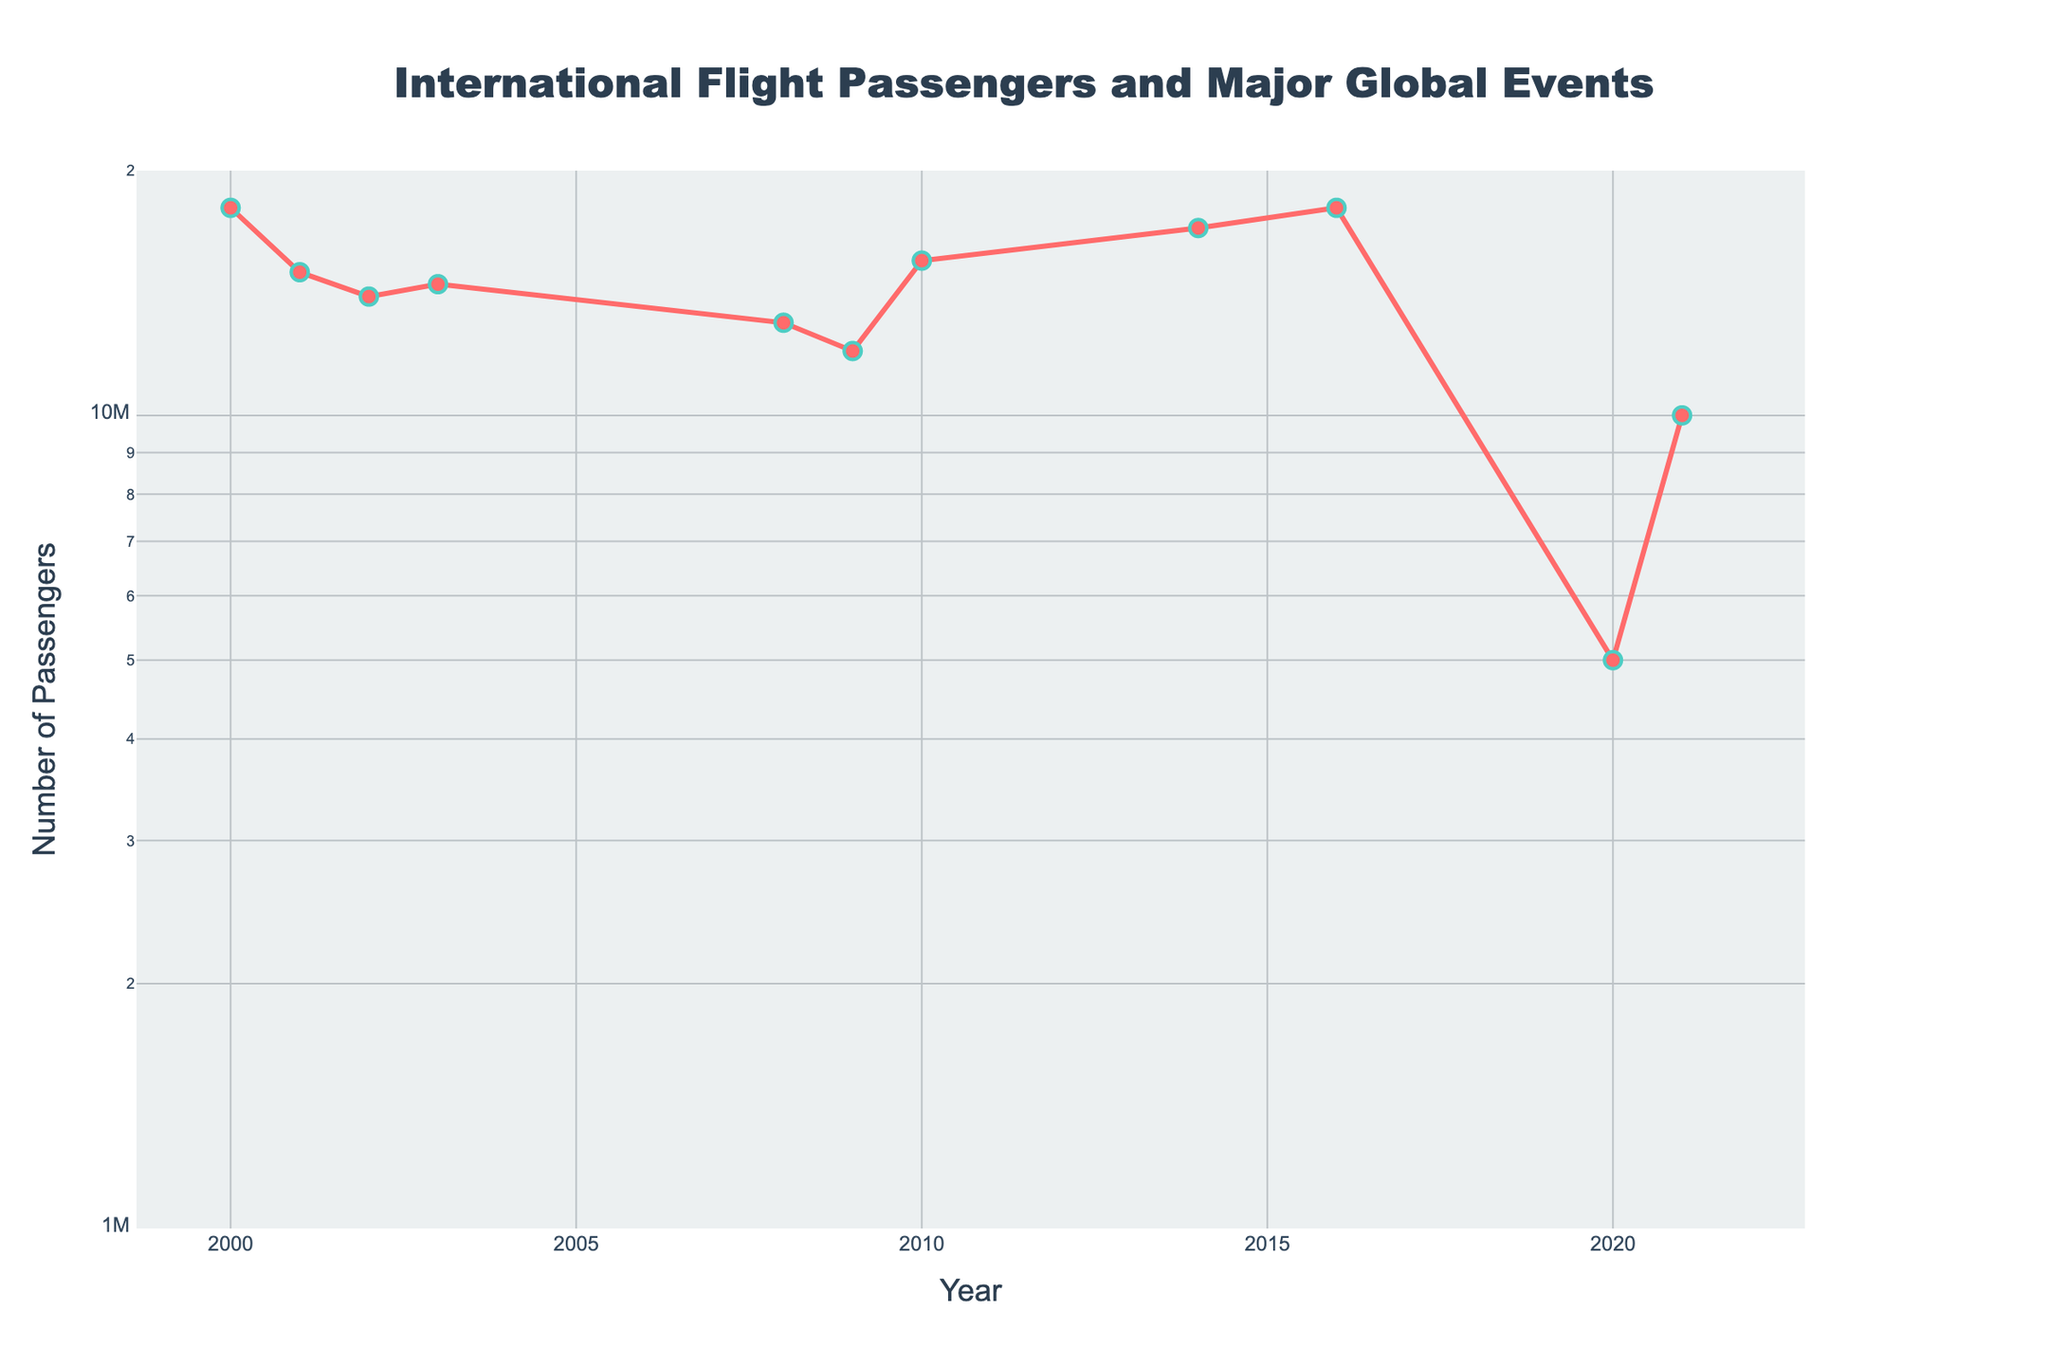What is the title of the plot? The title of the plot is located at the top center of the figure. It reads "International Flight Passengers and Major Global Events".
Answer: International Flight Passengers and Major Global Events What do the x-axis and y-axis represent? The x-axis is labeled "Year" and the y-axis is labeled "Number of Passengers". The y-axis uses a logarithmic scale to represent the number of passengers.
Answer: Year, Number of Passengers How many significant dips in passenger numbers are shown, and what major global events correlate with these dips? By examining the plot, significant dips in passenger numbers can be observed in the years 2001, 2008, 2009, and 2020. The correlating major global events are the 9/11 Attacks in 2001, the Global Financial Crisis in 2008, the H1N1 Influenza Pandemic in 2009, and the COVID-19 Pandemic in 2020.
Answer: Four significant dips: 2001 (9/11), 2008 (Global Financial Crisis), 2009 (H1N1), 2020 (COVID-19) Between which years did the number of passengers recover the most after a significant global event? The noticeable recovery occurs between the years 2009 and 2010. In 2009, the passenger number was 12,000,000 and increased to 15,500,000 in 2010, which is a clear sign of recovery post the H1N1 Influenza Pandemic.
Answer: Between 2009 and 2010 What was the approximate number of passengers in the year 2020 and which global event is associated with that year? The plot shows an approximate number of 5,000,000 passengers in the year 2020. This significant drop is associated with the COVID-19 Pandemic.
Answer: 5,000,000 passengers, COVID-19 Pandemic How does the number of passengers in 2016 compare to the number in 2014? By observing the plot, we can see that the number of passengers in 2016 is 18,000,000, while in 2014 it is 17,000,000. Therefore, there is an increase in the number of passengers from 2014 to 2016.
Answer: 2016 has 1,000,000 more passengers than 2014 What is the trend of the number of passengers from 2000 to 2002 and which major events may have contributed to this trend? The number of passengers decreases from 18,000,000 in 2000 to 15,000,000 in 2001, then further to 14,000,000 in 2002. This downward trend can be attributed to the Dot-com bubble burst in 2000, the 9/11 Attacks in 2001, and the SARS Outbreak in 2002.
Answer: Downward trend from 2000 to 2002, Dot-com bubble burst, 9/11 Attacks, SARS Outbreak Which year shows the most significant recovery after a major drop and what are the associated events? The year 2021 shows a significant recovery, with passenger numbers increasing from 5,000,000 in 2020 to 10,000,000 in 2021. This recovery follows the sharp decline due to the COVID-19 Pandemic in 2020.
Answer: 2021, Post COVID-19 Pandemic recovery What is the highest number of passengers recorded in the plot and in which year did this occur? The highest number of passengers recorded in the plot is 18,000,000. This value is observed in the years 2000 and 2016.
Answer: 18,000,000 passengers, 2000 and 2016 